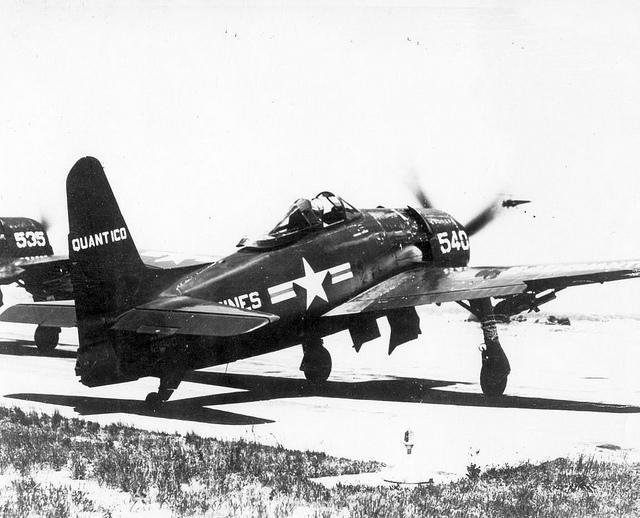How many airplanes are there?
Give a very brief answer. 2. How many wine bottles do you see?
Give a very brief answer. 0. 